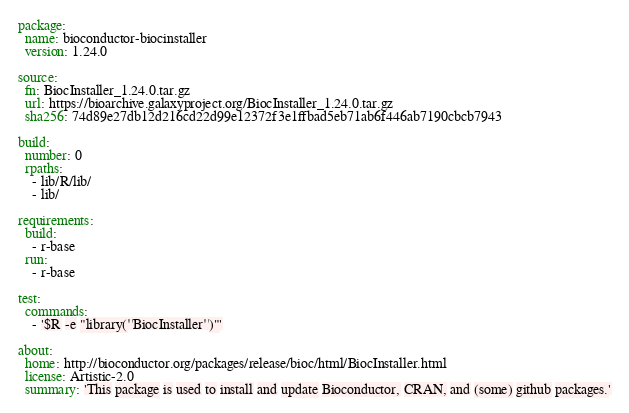<code> <loc_0><loc_0><loc_500><loc_500><_YAML_>package:
  name: bioconductor-biocinstaller
  version: 1.24.0

source:
  fn: BiocInstaller_1.24.0.tar.gz
  url: https://bioarchive.galaxyproject.org/BiocInstaller_1.24.0.tar.gz
  sha256: 74d89e27db12d216cd22d99e12372f3e1ffbad5eb71ab6f446ab7190cbcb7943

build:
  number: 0
  rpaths:
    - lib/R/lib/
    - lib/

requirements:
  build:
    - r-base
  run:
    - r-base

test:
  commands:
    - '$R -e "library(''BiocInstaller'')"'

about:
  home: http://bioconductor.org/packages/release/bioc/html/BiocInstaller.html
  license: Artistic-2.0
  summary: 'This package is used to install and update Bioconductor, CRAN, and (some) github packages.'
</code> 